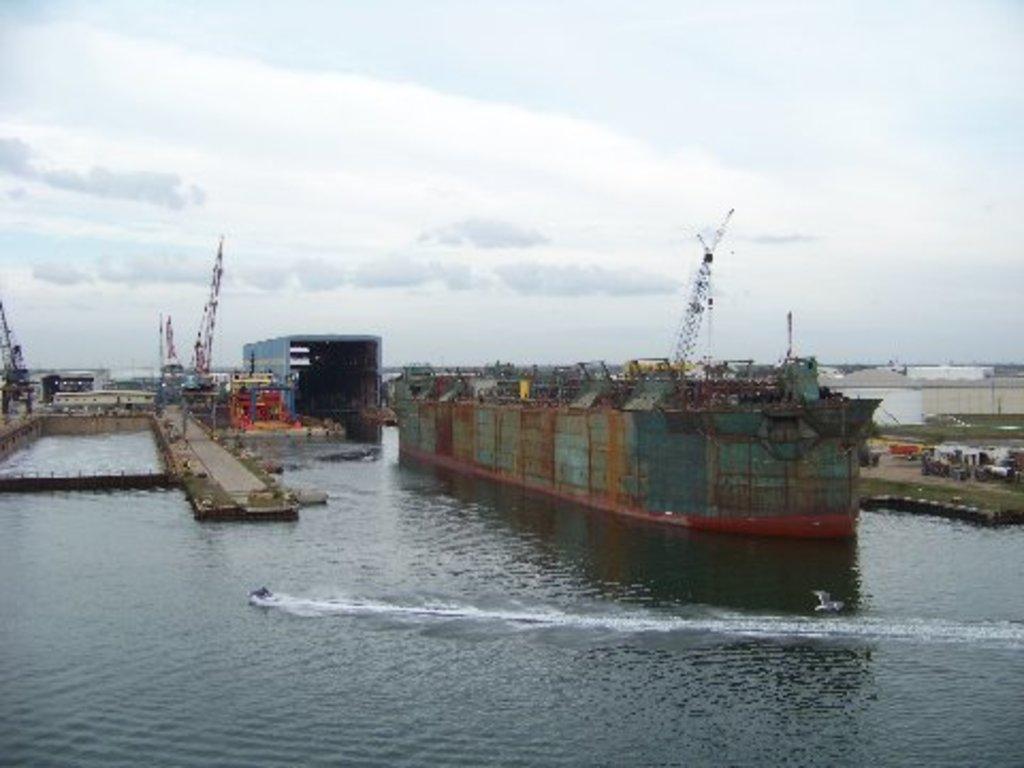Please provide a concise description of this image. There is a ship on the water on which, there are boats. In the background, there are buildings, grass and other objects on the ground and there are clouds in the sky. 